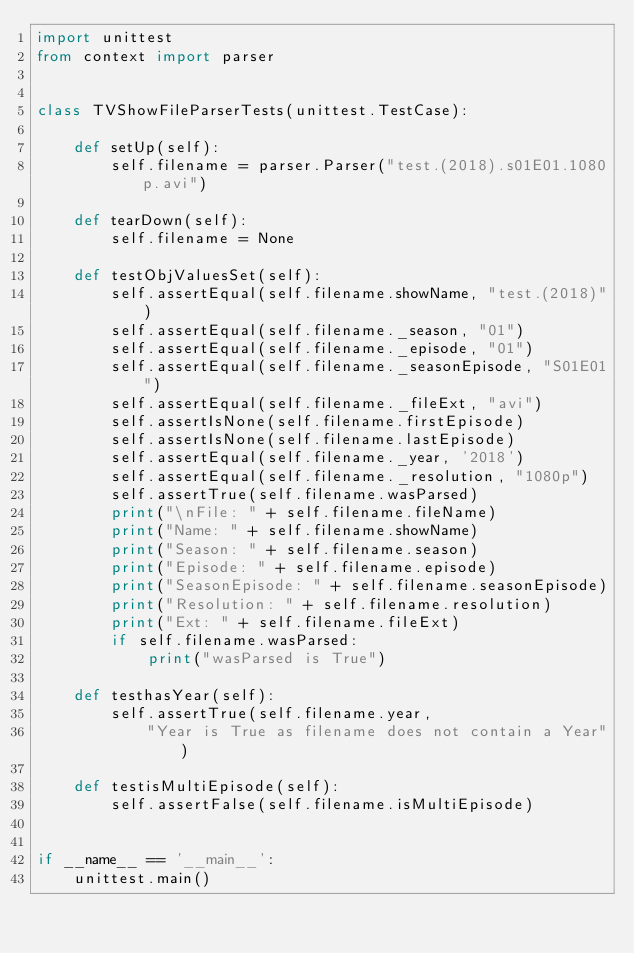Convert code to text. <code><loc_0><loc_0><loc_500><loc_500><_Python_>import unittest
from context import parser


class TVShowFileParserTests(unittest.TestCase):

    def setUp(self):
        self.filename = parser.Parser("test.(2018).s01E01.1080p.avi")

    def tearDown(self):
        self.filename = None

    def testObjValuesSet(self):
        self.assertEqual(self.filename.showName, "test.(2018)")
        self.assertEqual(self.filename._season, "01")
        self.assertEqual(self.filename._episode, "01")
        self.assertEqual(self.filename._seasonEpisode, "S01E01")
        self.assertEqual(self.filename._fileExt, "avi")
        self.assertIsNone(self.filename.firstEpisode)
        self.assertIsNone(self.filename.lastEpisode)
        self.assertEqual(self.filename._year, '2018')
        self.assertEqual(self.filename._resolution, "1080p")
        self.assertTrue(self.filename.wasParsed)
        print("\nFile: " + self.filename.fileName)
        print("Name: " + self.filename.showName)
        print("Season: " + self.filename.season)
        print("Episode: " + self.filename.episode)
        print("SeasonEpisode: " + self.filename.seasonEpisode)
        print("Resolution: " + self.filename.resolution)
        print("Ext: " + self.filename.fileExt)
        if self.filename.wasParsed:
            print("wasParsed is True")

    def testhasYear(self):
        self.assertTrue(self.filename.year,
            "Year is True as filename does not contain a Year")

    def testisMultiEpisode(self):
        self.assertFalse(self.filename.isMultiEpisode)


if __name__ == '__main__':
    unittest.main()
</code> 